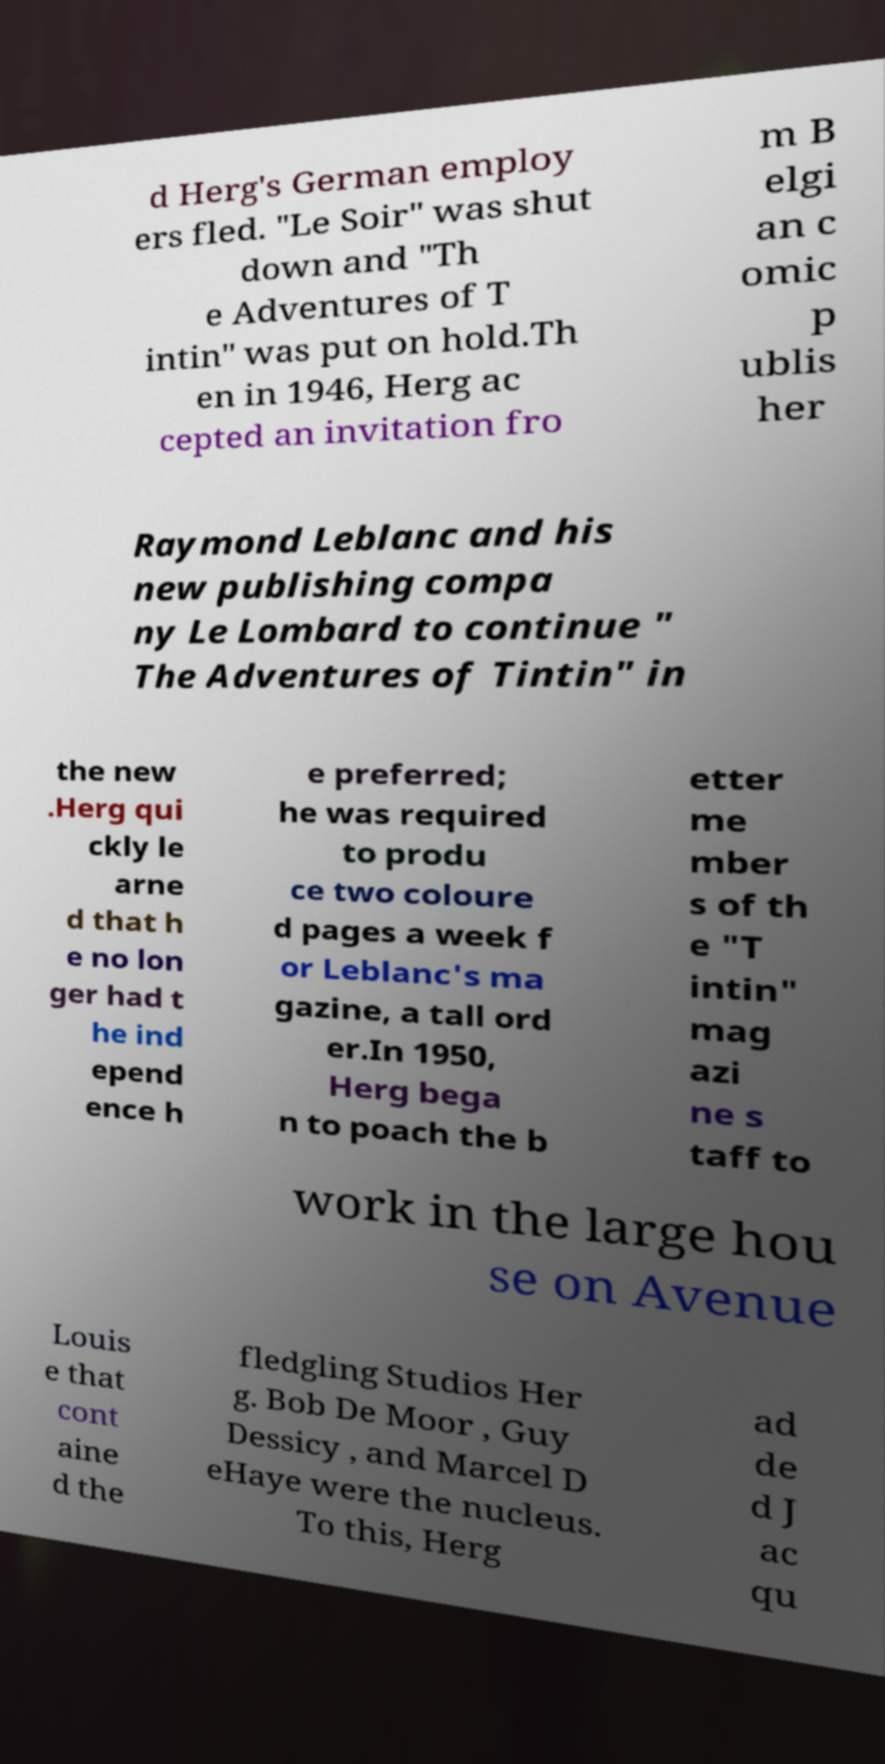Could you assist in decoding the text presented in this image and type it out clearly? d Herg's German employ ers fled. "Le Soir" was shut down and "Th e Adventures of T intin" was put on hold.Th en in 1946, Herg ac cepted an invitation fro m B elgi an c omic p ublis her Raymond Leblanc and his new publishing compa ny Le Lombard to continue " The Adventures of Tintin" in the new .Herg qui ckly le arne d that h e no lon ger had t he ind epend ence h e preferred; he was required to produ ce two coloure d pages a week f or Leblanc's ma gazine, a tall ord er.In 1950, Herg bega n to poach the b etter me mber s of th e "T intin" mag azi ne s taff to work in the large hou se on Avenue Louis e that cont aine d the fledgling Studios Her g. Bob De Moor , Guy Dessicy , and Marcel D eHaye were the nucleus. To this, Herg ad de d J ac qu 